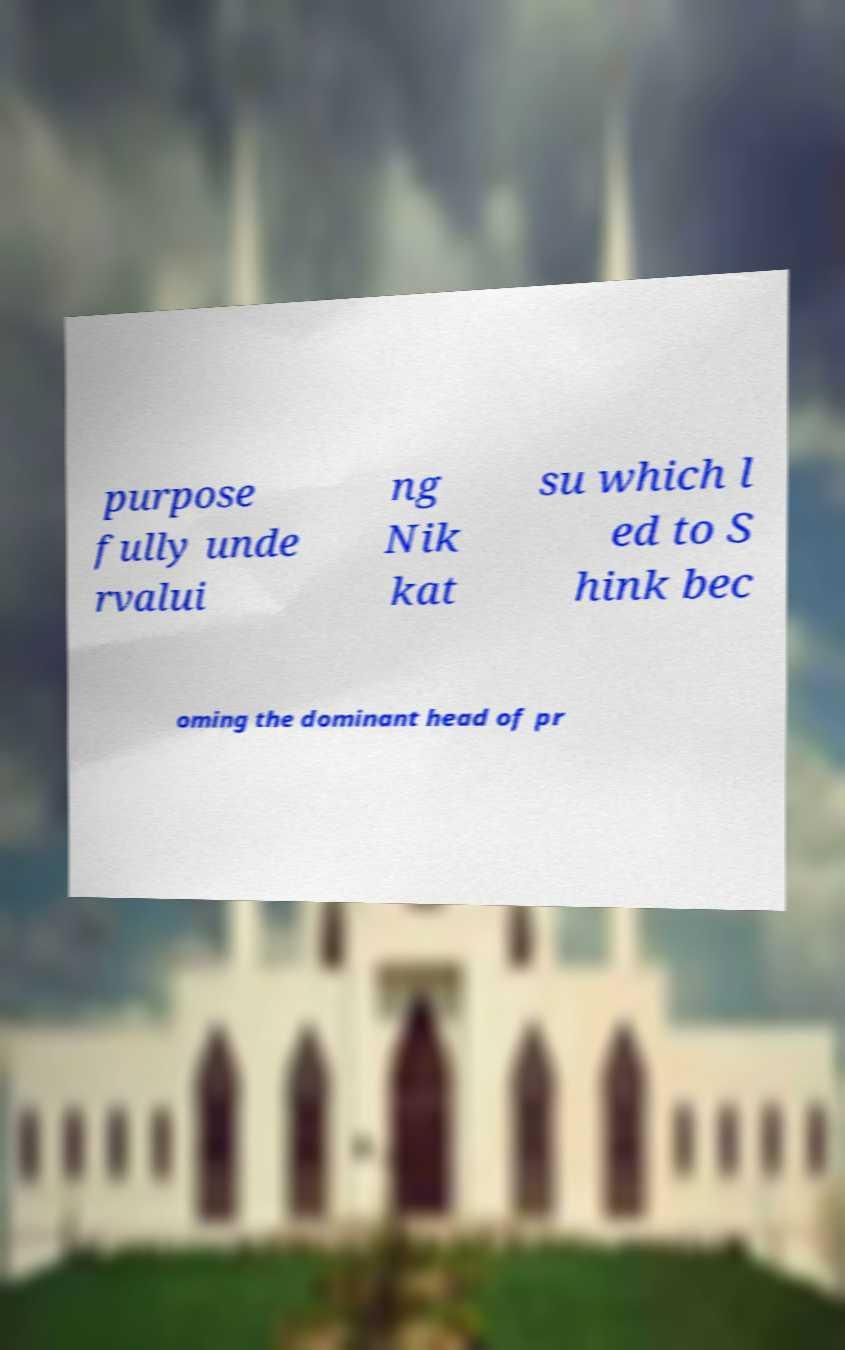Could you assist in decoding the text presented in this image and type it out clearly? purpose fully unde rvalui ng Nik kat su which l ed to S hink bec oming the dominant head of pr 